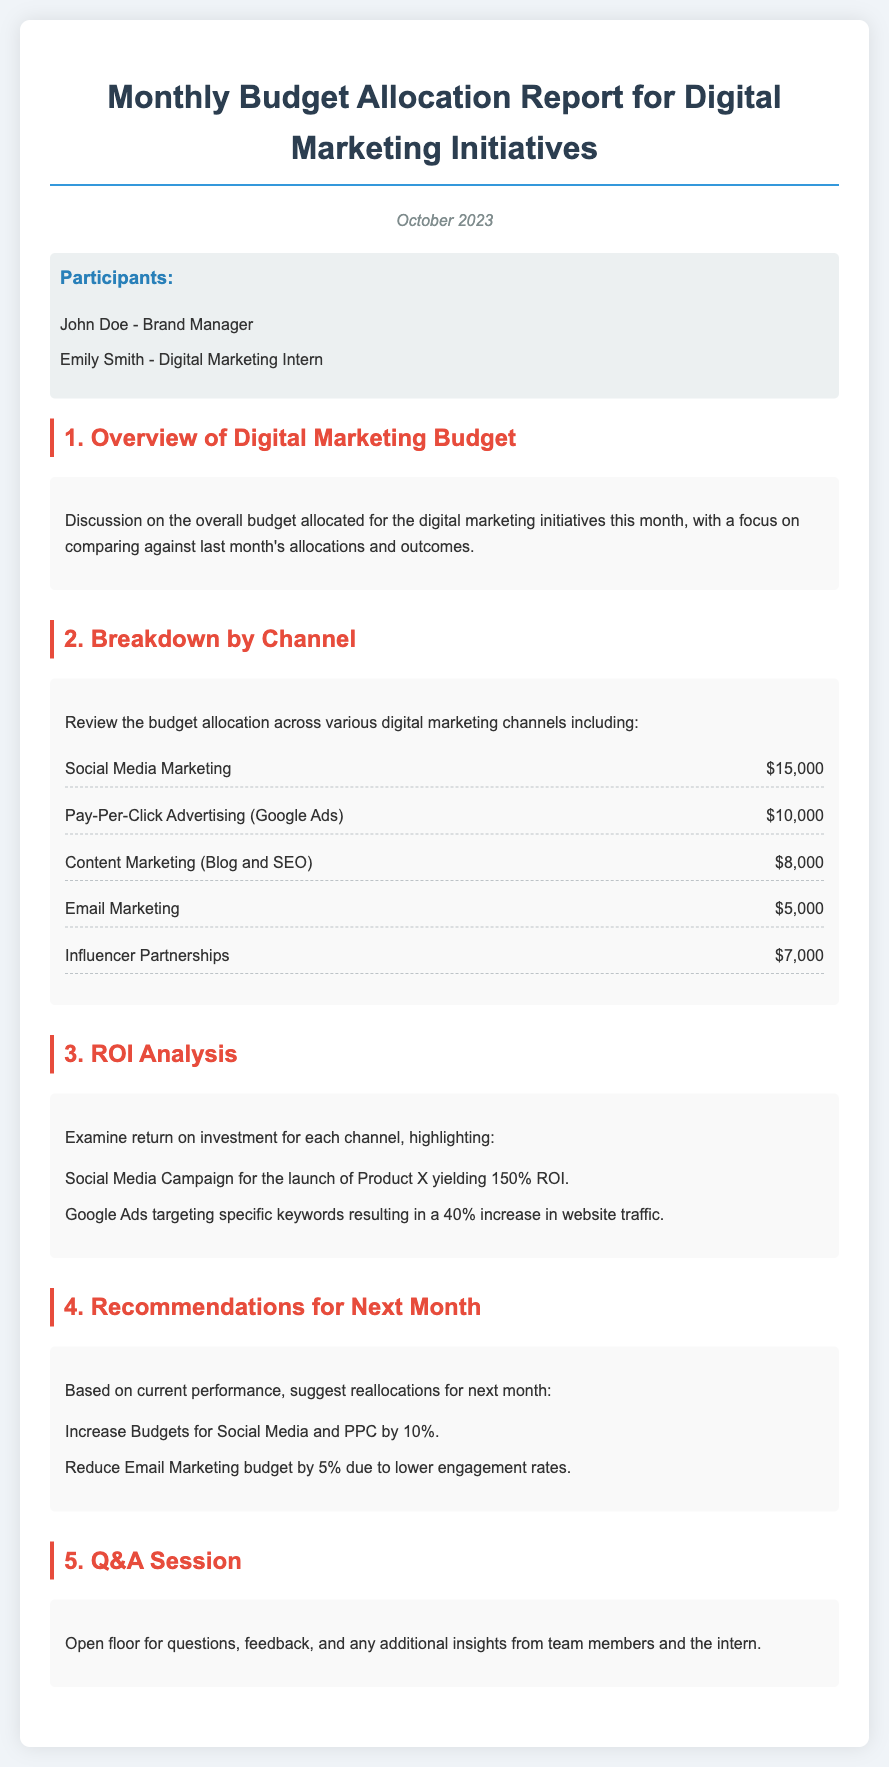What is the total allocated budget for Social Media Marketing? The document specifies the budget allocation for Social Media Marketing as $15,000.
Answer: $15,000 Which channel has the lowest budget allocation? By comparing the listed budgets, Email Marketing has the lowest allocation at $5,000.
Answer: $5,000 What is the ROI percentage for the Social Media Campaign for Product X? The document states that the ROI for the Social Media Campaign is 150%.
Answer: 150% How much is recommended to increase the budget for Social Media? The recommendation is to increase the budget for Social Media by 10%.
Answer: 10% Who are the participants in the budget meeting? The document lists John Doe and Emily Smith as the participants.
Answer: John Doe, Emily Smith What is the budget allocated for Pay-Per-Click Advertising? The document allocates $10,000 for Pay-Per-Click Advertising.
Answer: $10,000 What change is suggested for the Email Marketing budget? The suggestion is to reduce the Email Marketing budget by 5%.
Answer: Reduce by 5% What is the date of the Monthly Budget Allocation Report? The report is dated October 2023.
Answer: October 2023 What is the total allocated budget for Content Marketing? The total budget for Content Marketing is stated as $8,000.
Answer: $8,000 